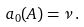Convert formula to latex. <formula><loc_0><loc_0><loc_500><loc_500>a _ { 0 } ( A ) = \nu \, .</formula> 